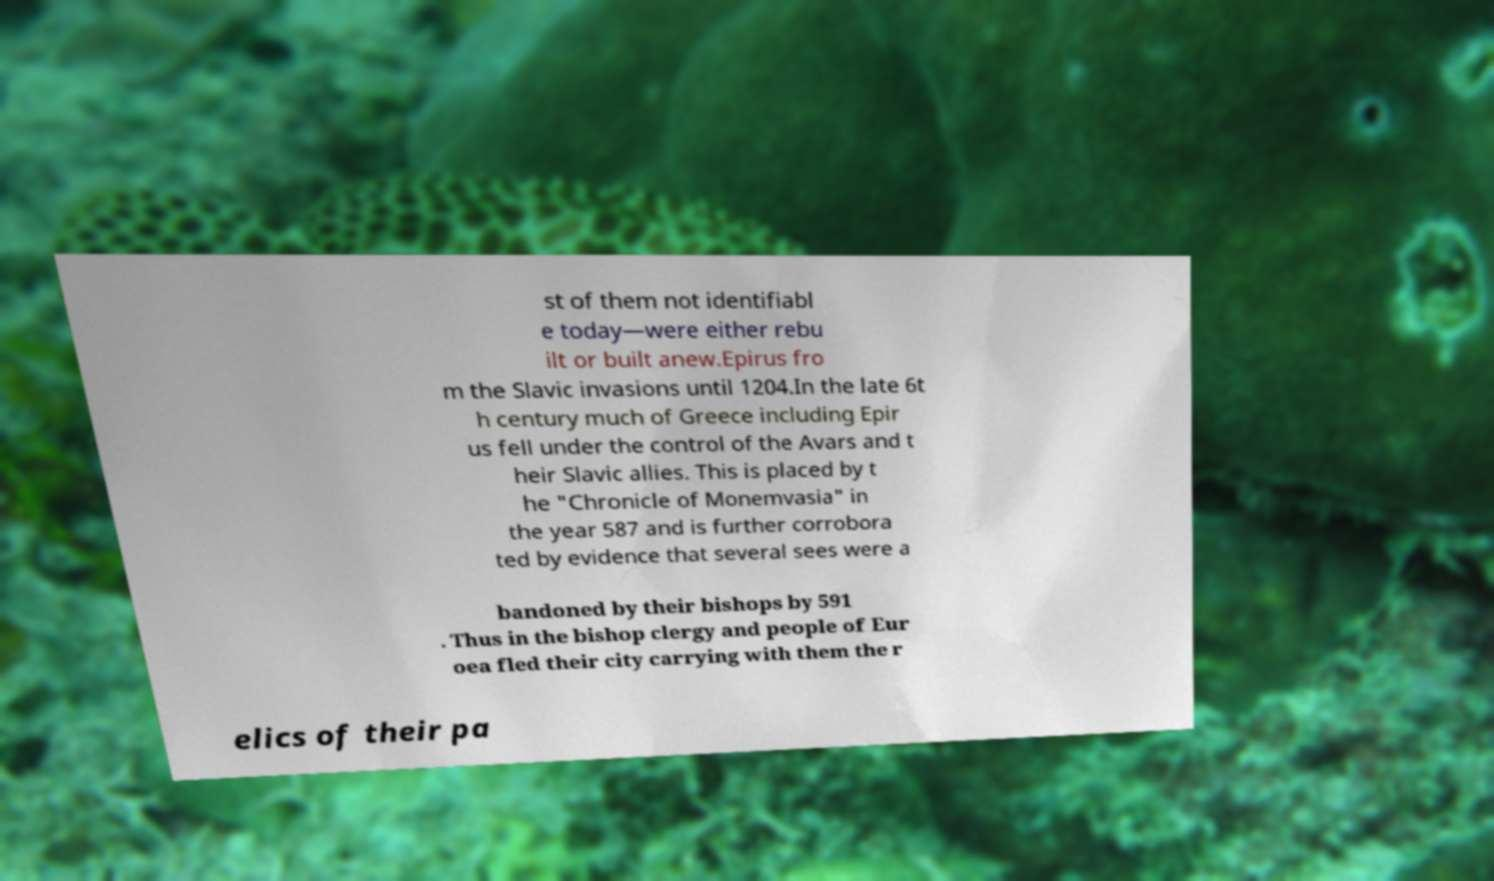There's text embedded in this image that I need extracted. Can you transcribe it verbatim? st of them not identifiabl e today—were either rebu ilt or built anew.Epirus fro m the Slavic invasions until 1204.In the late 6t h century much of Greece including Epir us fell under the control of the Avars and t heir Slavic allies. This is placed by t he "Chronicle of Monemvasia" in the year 587 and is further corrobora ted by evidence that several sees were a bandoned by their bishops by 591 . Thus in the bishop clergy and people of Eur oea fled their city carrying with them the r elics of their pa 